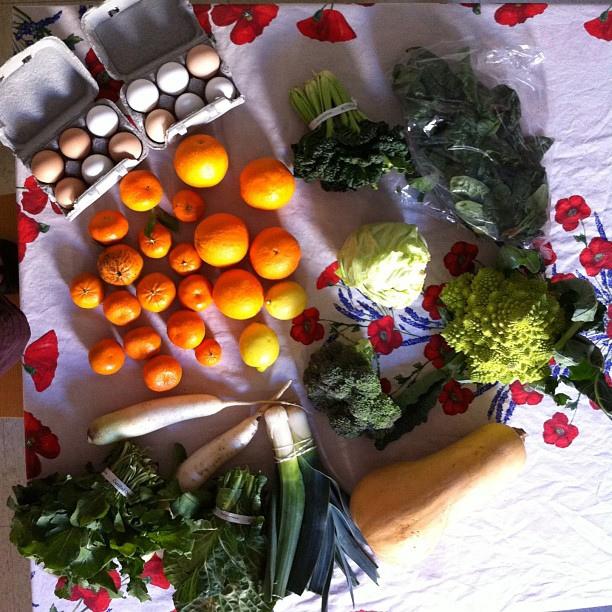Are these items healthy?
Give a very brief answer. Yes. How many lemons are there?
Concise answer only. 2. Was this produce purchased from a chain supermarket?
Short answer required. No. What kind of vegetables are in here?
Give a very brief answer. Broccoli,lettuce, kale. How many brown eggs are there?
Concise answer only. 6. How many vegetables are there?
Quick response, please. 8. 